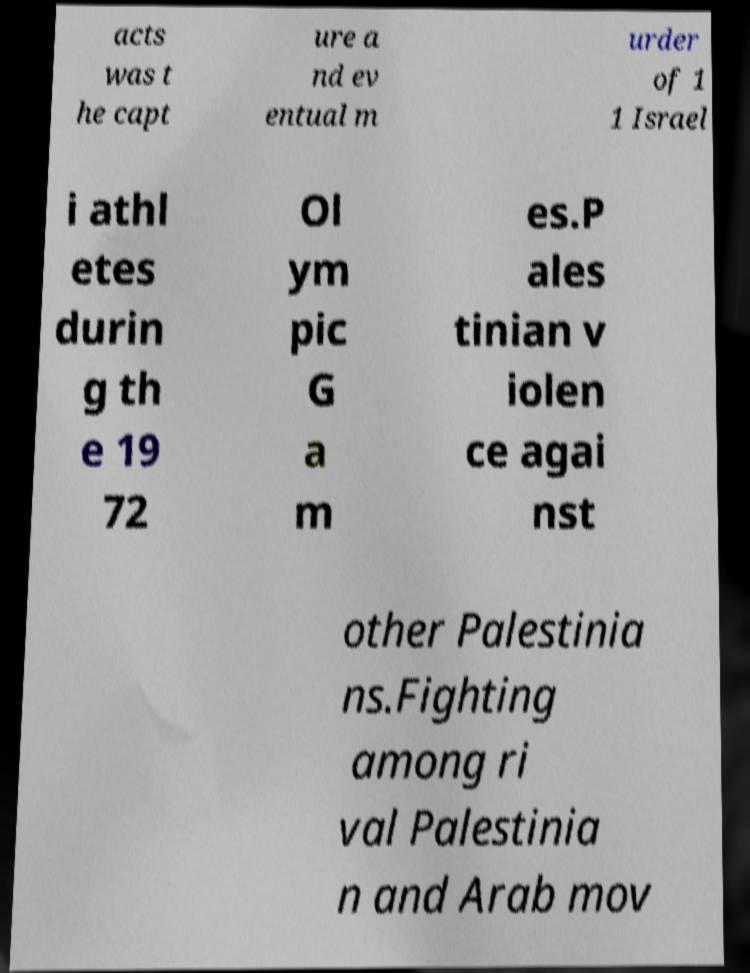What messages or text are displayed in this image? I need them in a readable, typed format. acts was t he capt ure a nd ev entual m urder of 1 1 Israel i athl etes durin g th e 19 72 Ol ym pic G a m es.P ales tinian v iolen ce agai nst other Palestinia ns.Fighting among ri val Palestinia n and Arab mov 